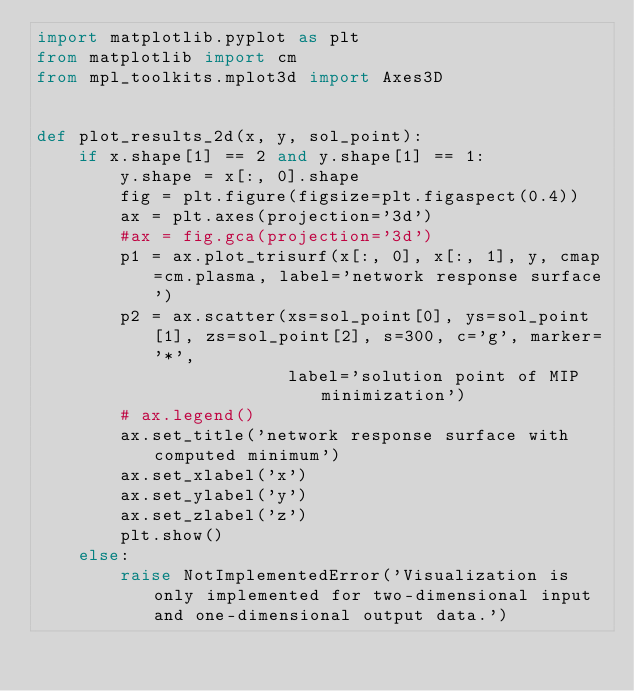<code> <loc_0><loc_0><loc_500><loc_500><_Python_>import matplotlib.pyplot as plt
from matplotlib import cm
from mpl_toolkits.mplot3d import Axes3D


def plot_results_2d(x, y, sol_point):
    if x.shape[1] == 2 and y.shape[1] == 1:
        y.shape = x[:, 0].shape
        fig = plt.figure(figsize=plt.figaspect(0.4))
        ax = plt.axes(projection='3d')
        #ax = fig.gca(projection='3d')
        p1 = ax.plot_trisurf(x[:, 0], x[:, 1], y, cmap=cm.plasma, label='network response surface')
        p2 = ax.scatter(xs=sol_point[0], ys=sol_point[1], zs=sol_point[2], s=300, c='g', marker='*',
                        label='solution point of MIP minimization')
        # ax.legend()
        ax.set_title('network response surface with computed minimum')
        ax.set_xlabel('x')
        ax.set_ylabel('y')
        ax.set_zlabel('z')
        plt.show()
    else:
        raise NotImplementedError('Visualization is only implemented for two-dimensional input and one-dimensional output data.')
</code> 